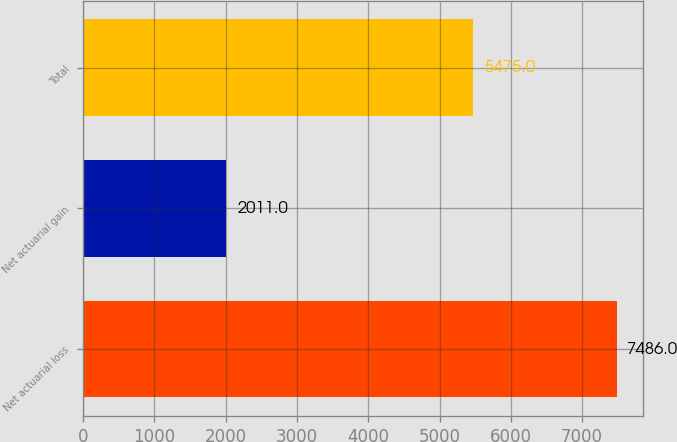Convert chart. <chart><loc_0><loc_0><loc_500><loc_500><bar_chart><fcel>Net actuarial loss<fcel>Net actuarial gain<fcel>Total<nl><fcel>7486<fcel>2011<fcel>5475<nl></chart> 